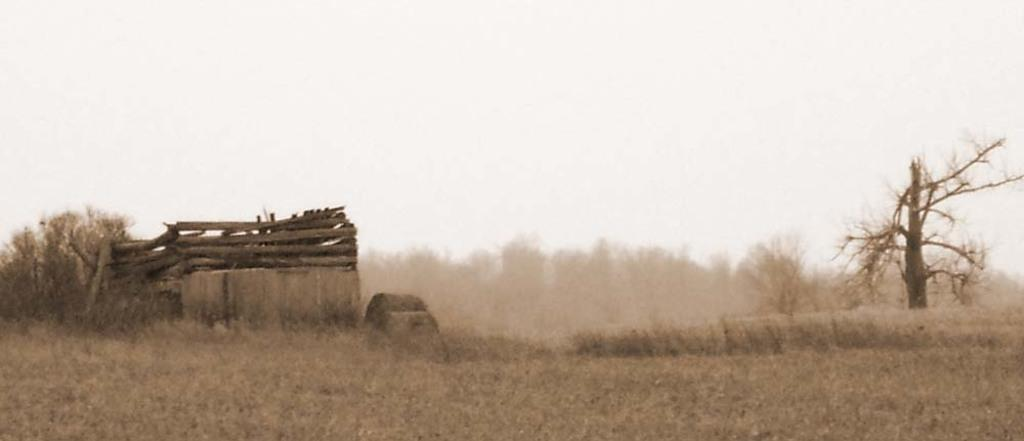What type of terrain is visible in the image? There is a dry grass field in the image. What structures can be seen in the image? There are three wooden rafters in the image. What type of vegetation is present in the image? There are dry trees in the image. What type of railway can be seen in the image? There is no railway present in the image. How far does the stretch of dry grass field extend in the image? The extent of the dry grass field cannot be determined from the image alone, as there is no reference point for measurement. 